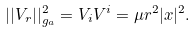<formula> <loc_0><loc_0><loc_500><loc_500>| | V _ { r } | | ^ { 2 } _ { g _ { a } } = V _ { i } V ^ { i } = \mu r ^ { 2 } | x | ^ { 2 } .</formula> 